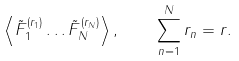Convert formula to latex. <formula><loc_0><loc_0><loc_500><loc_500>\left \langle \tilde { F } _ { 1 } ^ { ( r _ { 1 } ) } \dots \tilde { F } _ { N } ^ { ( r _ { N } ) } \right \rangle , \quad \sum _ { n = 1 } ^ { N } r _ { n } = r .</formula> 